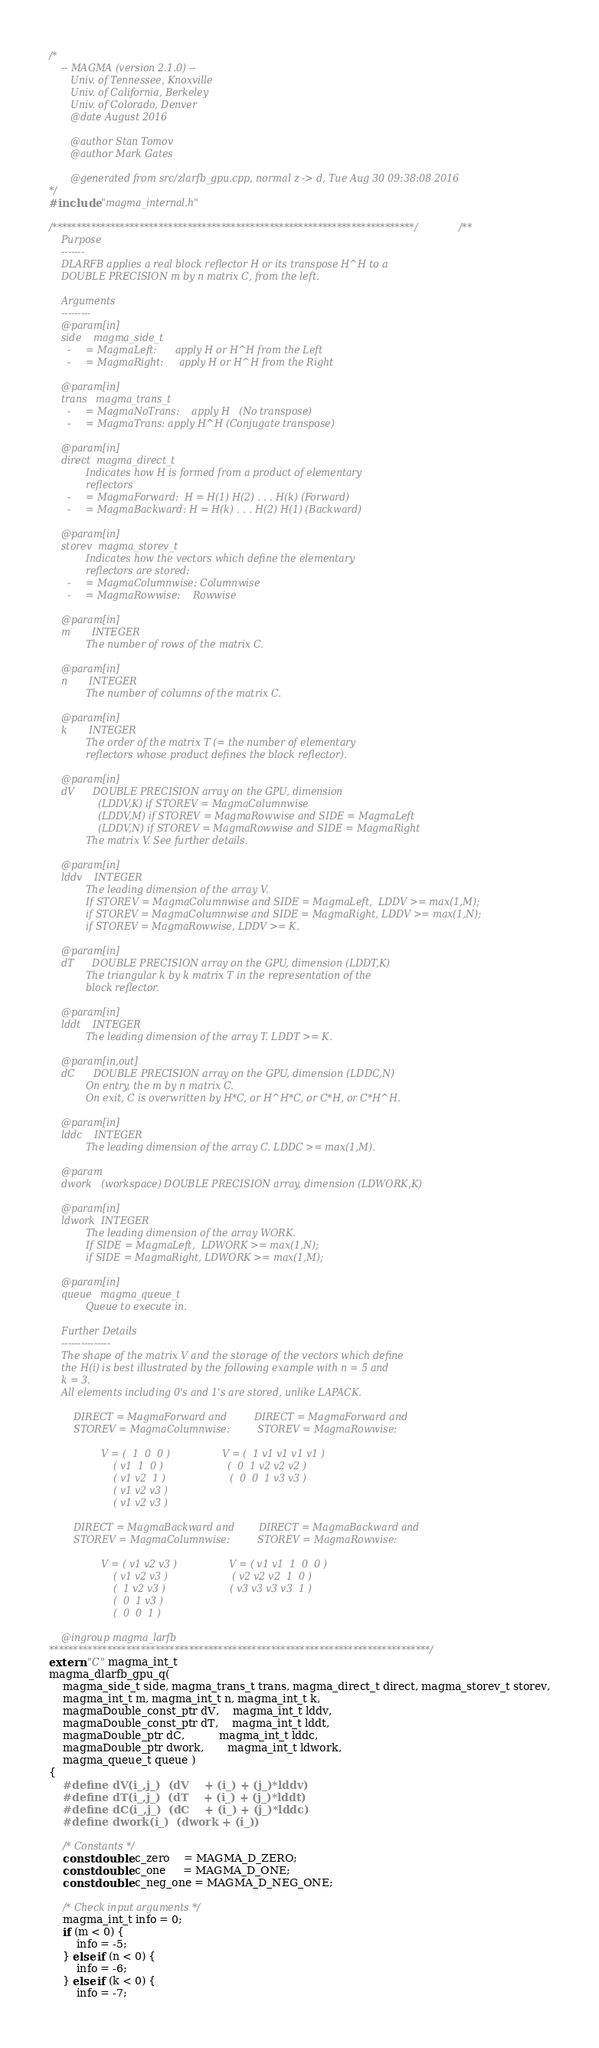<code> <loc_0><loc_0><loc_500><loc_500><_C++_>/*
    -- MAGMA (version 2.1.0) --
       Univ. of Tennessee, Knoxville
       Univ. of California, Berkeley
       Univ. of Colorado, Denver
       @date August 2016

       @author Stan Tomov
       @author Mark Gates
       
       @generated from src/zlarfb_gpu.cpp, normal z -> d, Tue Aug 30 09:38:08 2016
*/
#include "magma_internal.h"

/***************************************************************************//**
    Purpose
    -------
    DLARFB applies a real block reflector H or its transpose H^H to a
    DOUBLE PRECISION m by n matrix C, from the left.

    Arguments
    ---------
    @param[in]
    side    magma_side_t
      -     = MagmaLeft:      apply H or H^H from the Left
      -     = MagmaRight:     apply H or H^H from the Right

    @param[in]
    trans   magma_trans_t
      -     = MagmaNoTrans:    apply H   (No transpose)
      -     = MagmaTrans: apply H^H (Conjugate transpose)

    @param[in]
    direct  magma_direct_t
            Indicates how H is formed from a product of elementary
            reflectors
      -     = MagmaForward:  H = H(1) H(2) . . . H(k) (Forward)
      -     = MagmaBackward: H = H(k) . . . H(2) H(1) (Backward)

    @param[in]
    storev  magma_storev_t
            Indicates how the vectors which define the elementary
            reflectors are stored:
      -     = MagmaColumnwise: Columnwise
      -     = MagmaRowwise:    Rowwise

    @param[in]
    m       INTEGER
            The number of rows of the matrix C.

    @param[in]
    n       INTEGER
            The number of columns of the matrix C.

    @param[in]
    k       INTEGER
            The order of the matrix T (= the number of elementary
            reflectors whose product defines the block reflector).

    @param[in]
    dV      DOUBLE PRECISION array on the GPU, dimension
                (LDDV,K) if STOREV = MagmaColumnwise
                (LDDV,M) if STOREV = MagmaRowwise and SIDE = MagmaLeft
                (LDDV,N) if STOREV = MagmaRowwise and SIDE = MagmaRight
            The matrix V. See further details.

    @param[in]
    lddv    INTEGER
            The leading dimension of the array V.
            If STOREV = MagmaColumnwise and SIDE = MagmaLeft,  LDDV >= max(1,M);
            if STOREV = MagmaColumnwise and SIDE = MagmaRight, LDDV >= max(1,N);
            if STOREV = MagmaRowwise, LDDV >= K.

    @param[in]
    dT      DOUBLE PRECISION array on the GPU, dimension (LDDT,K)
            The triangular k by k matrix T in the representation of the
            block reflector.

    @param[in]
    lddt    INTEGER
            The leading dimension of the array T. LDDT >= K.

    @param[in,out]
    dC      DOUBLE PRECISION array on the GPU, dimension (LDDC,N)
            On entry, the m by n matrix C.
            On exit, C is overwritten by H*C, or H^H*C, or C*H, or C*H^H.

    @param[in]
    lddc    INTEGER
            The leading dimension of the array C. LDDC >= max(1,M).

    @param
    dwork   (workspace) DOUBLE PRECISION array, dimension (LDWORK,K)

    @param[in]
    ldwork  INTEGER
            The leading dimension of the array WORK.
            If SIDE = MagmaLeft,  LDWORK >= max(1,N);
            if SIDE = MagmaRight, LDWORK >= max(1,M);

    @param[in]
    queue   magma_queue_t
            Queue to execute in.

    Further Details
    ---------------
    The shape of the matrix V and the storage of the vectors which define
    the H(i) is best illustrated by the following example with n = 5 and
    k = 3.
    All elements including 0's and 1's are stored, unlike LAPACK.

        DIRECT = MagmaForward and         DIRECT = MagmaForward and
        STOREV = MagmaColumnwise:         STOREV = MagmaRowwise:

                 V = (  1  0  0 )                 V = (  1 v1 v1 v1 v1 )
                     ( v1  1  0 )                     (  0  1 v2 v2 v2 )
                     ( v1 v2  1 )                     (  0  0  1 v3 v3 )
                     ( v1 v2 v3 )
                     ( v1 v2 v3 )

        DIRECT = MagmaBackward and        DIRECT = MagmaBackward and
        STOREV = MagmaColumnwise:         STOREV = MagmaRowwise:

                 V = ( v1 v2 v3 )                 V = ( v1 v1  1  0  0 )
                     ( v1 v2 v3 )                     ( v2 v2 v2  1  0 )
                     (  1 v2 v3 )                     ( v3 v3 v3 v3  1 )
                     (  0  1 v3 )
                     (  0  0  1 )

    @ingroup magma_larfb
*******************************************************************************/
extern "C" magma_int_t
magma_dlarfb_gpu_q(
    magma_side_t side, magma_trans_t trans, magma_direct_t direct, magma_storev_t storev,
    magma_int_t m, magma_int_t n, magma_int_t k,
    magmaDouble_const_ptr dV,    magma_int_t lddv,
    magmaDouble_const_ptr dT,    magma_int_t lddt,
    magmaDouble_ptr dC,          magma_int_t lddc,
    magmaDouble_ptr dwork,       magma_int_t ldwork,
    magma_queue_t queue )
{
    #define dV(i_,j_)  (dV    + (i_) + (j_)*lddv)
    #define dT(i_,j_)  (dT    + (i_) + (j_)*lddt)
    #define dC(i_,j_)  (dC    + (i_) + (j_)*lddc)
    #define dwork(i_)  (dwork + (i_))
    
    /* Constants */
    const double c_zero    = MAGMA_D_ZERO;
    const double c_one     = MAGMA_D_ONE;
    const double c_neg_one = MAGMA_D_NEG_ONE;
    
    /* Check input arguments */
    magma_int_t info = 0;
    if (m < 0) {
        info = -5;
    } else if (n < 0) {
        info = -6;
    } else if (k < 0) {
        info = -7;</code> 